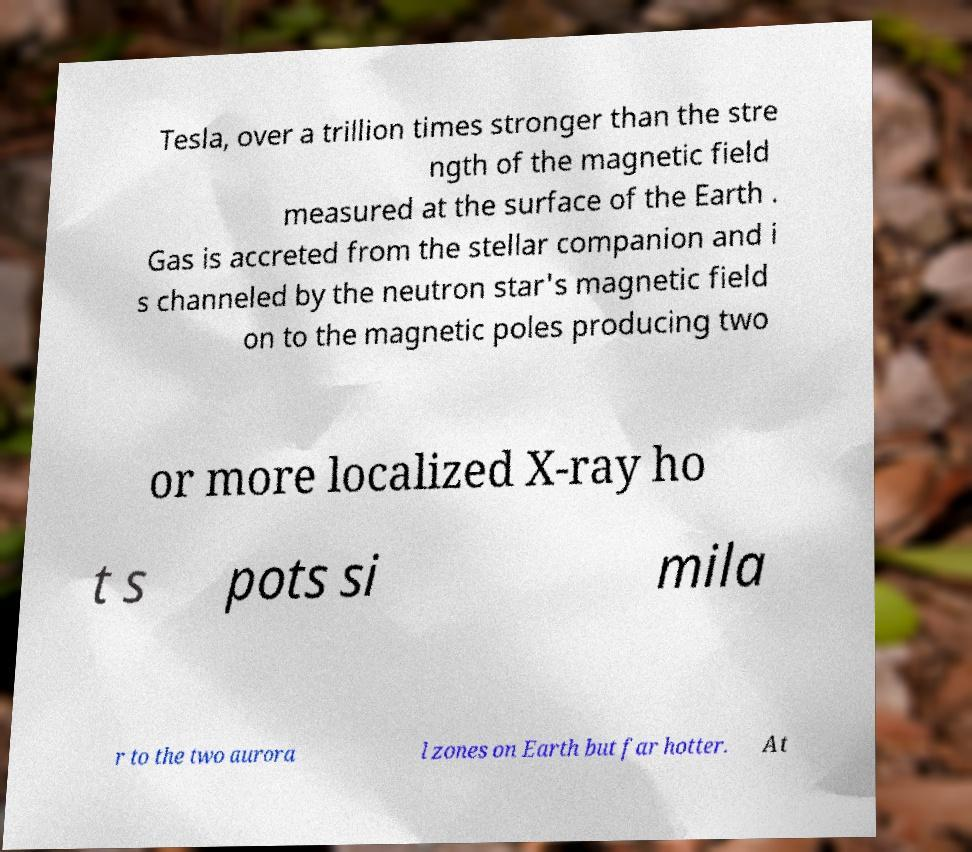I need the written content from this picture converted into text. Can you do that? Tesla, over a trillion times stronger than the stre ngth of the magnetic field measured at the surface of the Earth . Gas is accreted from the stellar companion and i s channeled by the neutron star's magnetic field on to the magnetic poles producing two or more localized X-ray ho t s pots si mila r to the two aurora l zones on Earth but far hotter. At 